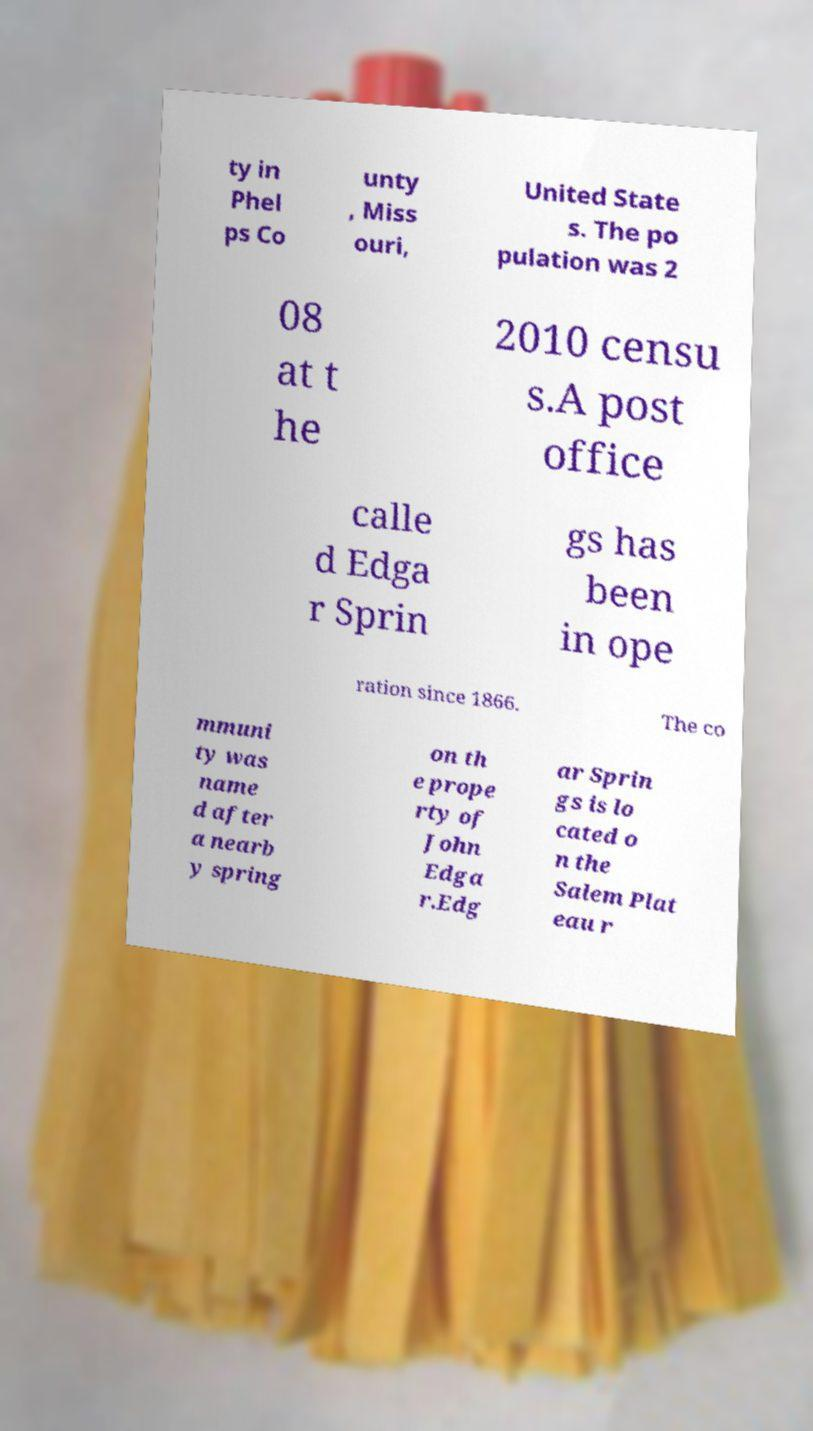I need the written content from this picture converted into text. Can you do that? ty in Phel ps Co unty , Miss ouri, United State s. The po pulation was 2 08 at t he 2010 censu s.A post office calle d Edga r Sprin gs has been in ope ration since 1866. The co mmuni ty was name d after a nearb y spring on th e prope rty of John Edga r.Edg ar Sprin gs is lo cated o n the Salem Plat eau r 